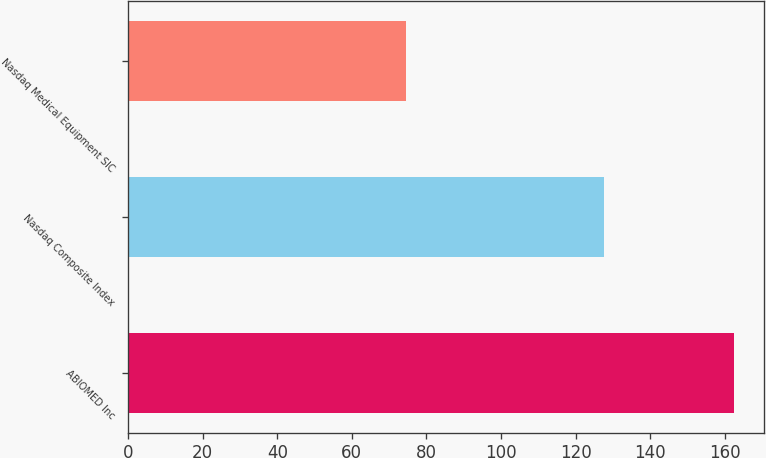Convert chart to OTSL. <chart><loc_0><loc_0><loc_500><loc_500><bar_chart><fcel>ABIOMED Inc<fcel>Nasdaq Composite Index<fcel>Nasdaq Medical Equipment SIC<nl><fcel>162.45<fcel>127.66<fcel>74.4<nl></chart> 